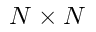<formula> <loc_0><loc_0><loc_500><loc_500>N \times N</formula> 